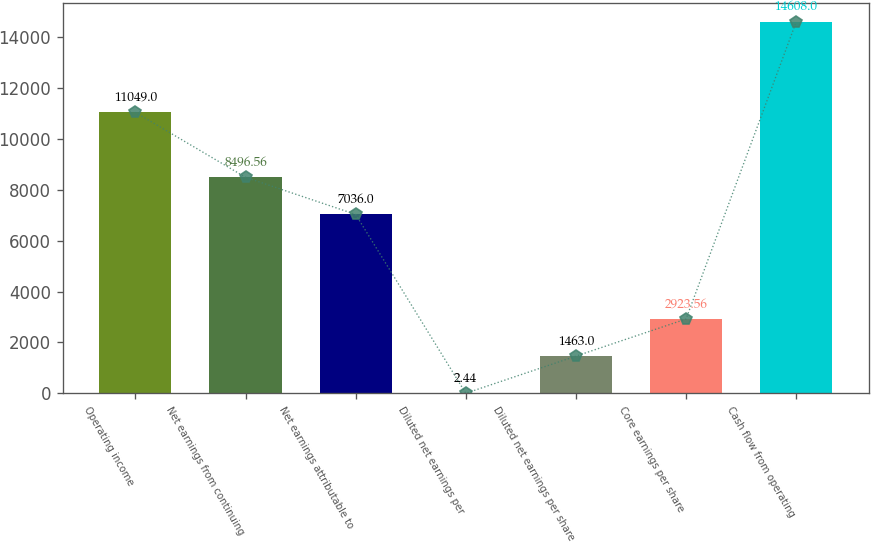Convert chart. <chart><loc_0><loc_0><loc_500><loc_500><bar_chart><fcel>Operating income<fcel>Net earnings from continuing<fcel>Net earnings attributable to<fcel>Diluted net earnings per<fcel>Diluted net earnings per share<fcel>Core earnings per share<fcel>Cash flow from operating<nl><fcel>11049<fcel>8496.56<fcel>7036<fcel>2.44<fcel>1463<fcel>2923.56<fcel>14608<nl></chart> 